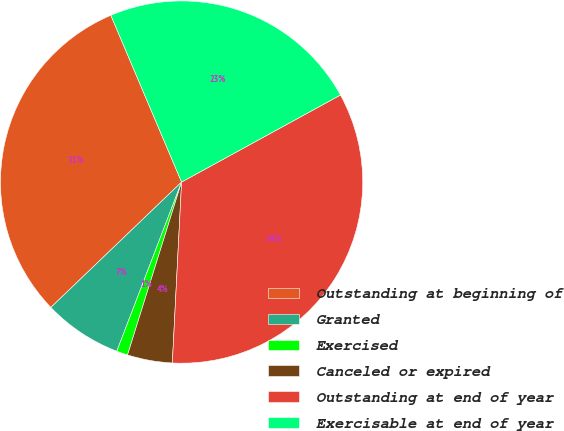Convert chart. <chart><loc_0><loc_0><loc_500><loc_500><pie_chart><fcel>Outstanding at beginning of<fcel>Granted<fcel>Exercised<fcel>Canceled or expired<fcel>Outstanding at end of year<fcel>Exercisable at end of year<nl><fcel>30.78%<fcel>7.01%<fcel>1.0%<fcel>4.01%<fcel>33.79%<fcel>23.41%<nl></chart> 